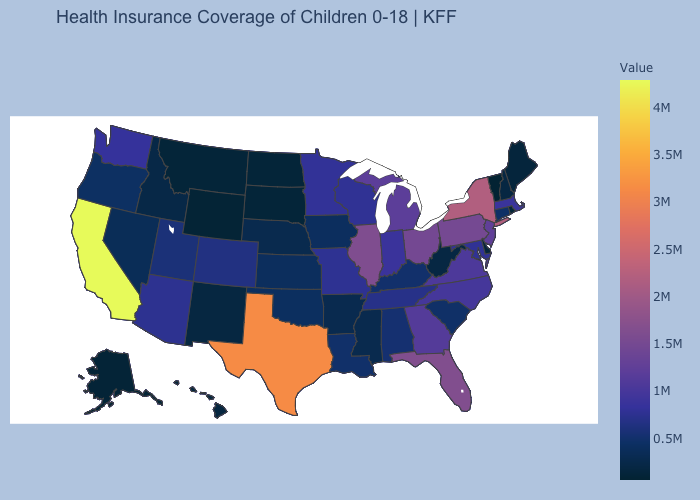Which states have the lowest value in the USA?
Be succinct. Vermont. Among the states that border Kentucky , which have the highest value?
Be succinct. Illinois. Among the states that border Pennsylvania , does New York have the highest value?
Concise answer only. Yes. Does Maryland have the highest value in the USA?
Short answer required. No. 